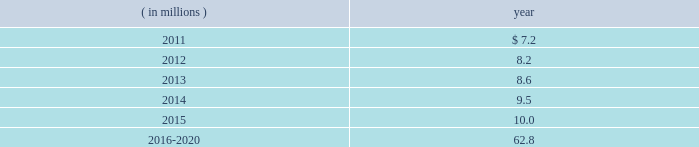The company expects to amortize $ 1.7 million of actuarial loss from accumulated other comprehensive income ( loss ) into net periodic benefit costs in 2011 .
At december 31 , 2010 , anticipated benefit payments from the plan in future years are as follows: .
Savings plans .
Cme maintains a defined contribution savings plan pursuant to section 401 ( k ) of the internal revenue code , whereby all u.s .
Employees are participants and have the option to contribute to this plan .
Cme matches employee contributions up to 3% ( 3 % ) of the employee 2019s base salary and may make additional discretionary contributions of up to 2% ( 2 % ) of base salary .
In addition , certain cme london-based employees are eligible to participate in a defined contribution plan .
For cme london-based employees , the plan provides for company contributions of 10% ( 10 % ) of earnings and does not have any vesting requirements .
Salary and cash bonuses paid are included in the definition of earnings .
Aggregate expense for all of the defined contribution savings plans amounted to $ 6.3 million , $ 5.2 million and $ 5.8 million in 2010 , 2009 and 2008 , respectively .
Cme non-qualified plans .
Cme maintains non-qualified plans , under which participants may make assumed investment choices with respect to amounts contributed on their behalf .
Although not required to do so , cme invests such contributions in assets that mirror the assumed investment choices .
The balances in these plans are subject to the claims of general creditors of the exchange and totaled $ 28.8 million and $ 23.4 million at december 31 , 2010 and 2009 , respectively .
Although the value of the plans is recorded as an asset in the consolidated balance sheets , there is an equal and offsetting liability .
The investment results of these plans have no impact on net income as the investment results are recorded in equal amounts to both investment income and compensation and benefits expense .
Supplemental savings plan 2014cme maintains a supplemental plan to provide benefits for employees who have been impacted by statutory limits under the provisions of the qualified pension and savings plan .
All cme employees hired prior to january 1 , 2007 are immediately vested in their supplemental plan benefits .
All cme employees hired on or after january 1 , 2007 are subject to the vesting requirements of the underlying qualified plans .
Total expense for the supplemental plan was $ 0.9 million , $ 0.7 million and $ 1.3 million for 2010 , 2009 and 2008 , respectively .
Deferred compensation plan 2014a deferred compensation plan is maintained by cme , under which eligible officers and members of the board of directors may contribute a percentage of their compensation and defer income taxes thereon until the time of distribution .
Nymexmembers 2019 retirement plan and benefits .
Nymex maintained a retirement and benefit plan under the commodities exchange , inc .
( comex ) members 2019 recognition and retention plan ( mrrp ) .
This plan provides benefits to certain members of the comex division based on long-term membership , and participation is limited to individuals who were comex division members prior to nymex 2019s acquisition of comex in 1994 .
No new participants were permitted into the plan after the date of this acquisition .
Under the terms of the mrrp , the company is required to fund the plan with a minimum annual contribution of $ 0.4 million until it is fully funded .
All benefits to be paid under the mrrp are based on reasonable actuarial assumptions which are based upon the amounts that are available and are expected to be available to pay benefits .
Total contributions to the plan were $ 0.8 million for each of 2010 , 2009 and for the period august 23 through december 31 , 2008 .
At december 31 , 2010 and 2009 , the total obligation for the mrrp totaled $ 20.7 million and $ 20.5 million .
What was the sum of total expense for the supplemental plan from 2008 to 2010? 
Computations: ((0.9 + 0.7) + 1.3)
Answer: 2.9. 